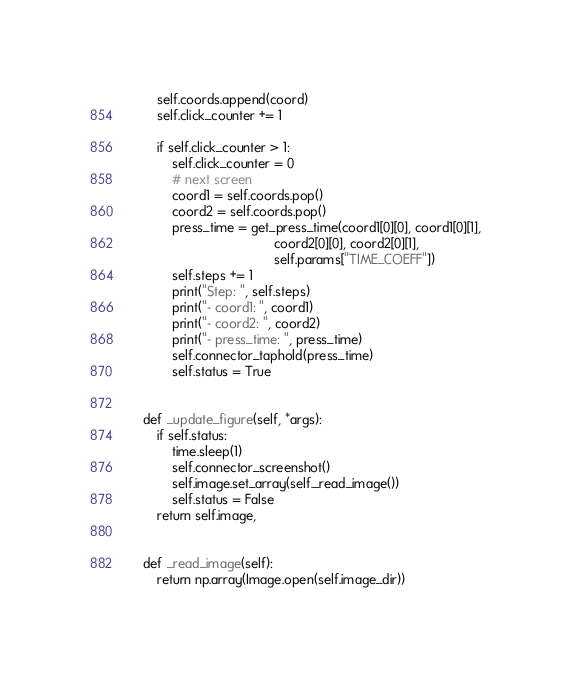<code> <loc_0><loc_0><loc_500><loc_500><_Python_>        self.coords.append(coord)
        self.click_counter += 1

        if self.click_counter > 1:
            self.click_counter = 0
            # next screen
            coord1 = self.coords.pop()
            coord2 = self.coords.pop()
            press_time = get_press_time(coord1[0][0], coord1[0][1],
                                        coord2[0][0], coord2[0][1], 
                                        self.params["TIME_COEFF"])
            self.steps += 1
            print("Step: ", self.steps)
            print("- coord1: ", coord1)
            print("- coord2: ", coord2)
            print("- press_time: ", press_time)
            self.connector_taphold(press_time)
            self.status = True


    def _update_figure(self, *args):
        if self.status:
            time.sleep(1)
            self.connector_screenshot()
            self.image.set_array(self._read_image())
            self.status = False
        return self.image,


    def _read_image(self):
        return np.array(Image.open(self.image_dir))
</code> 